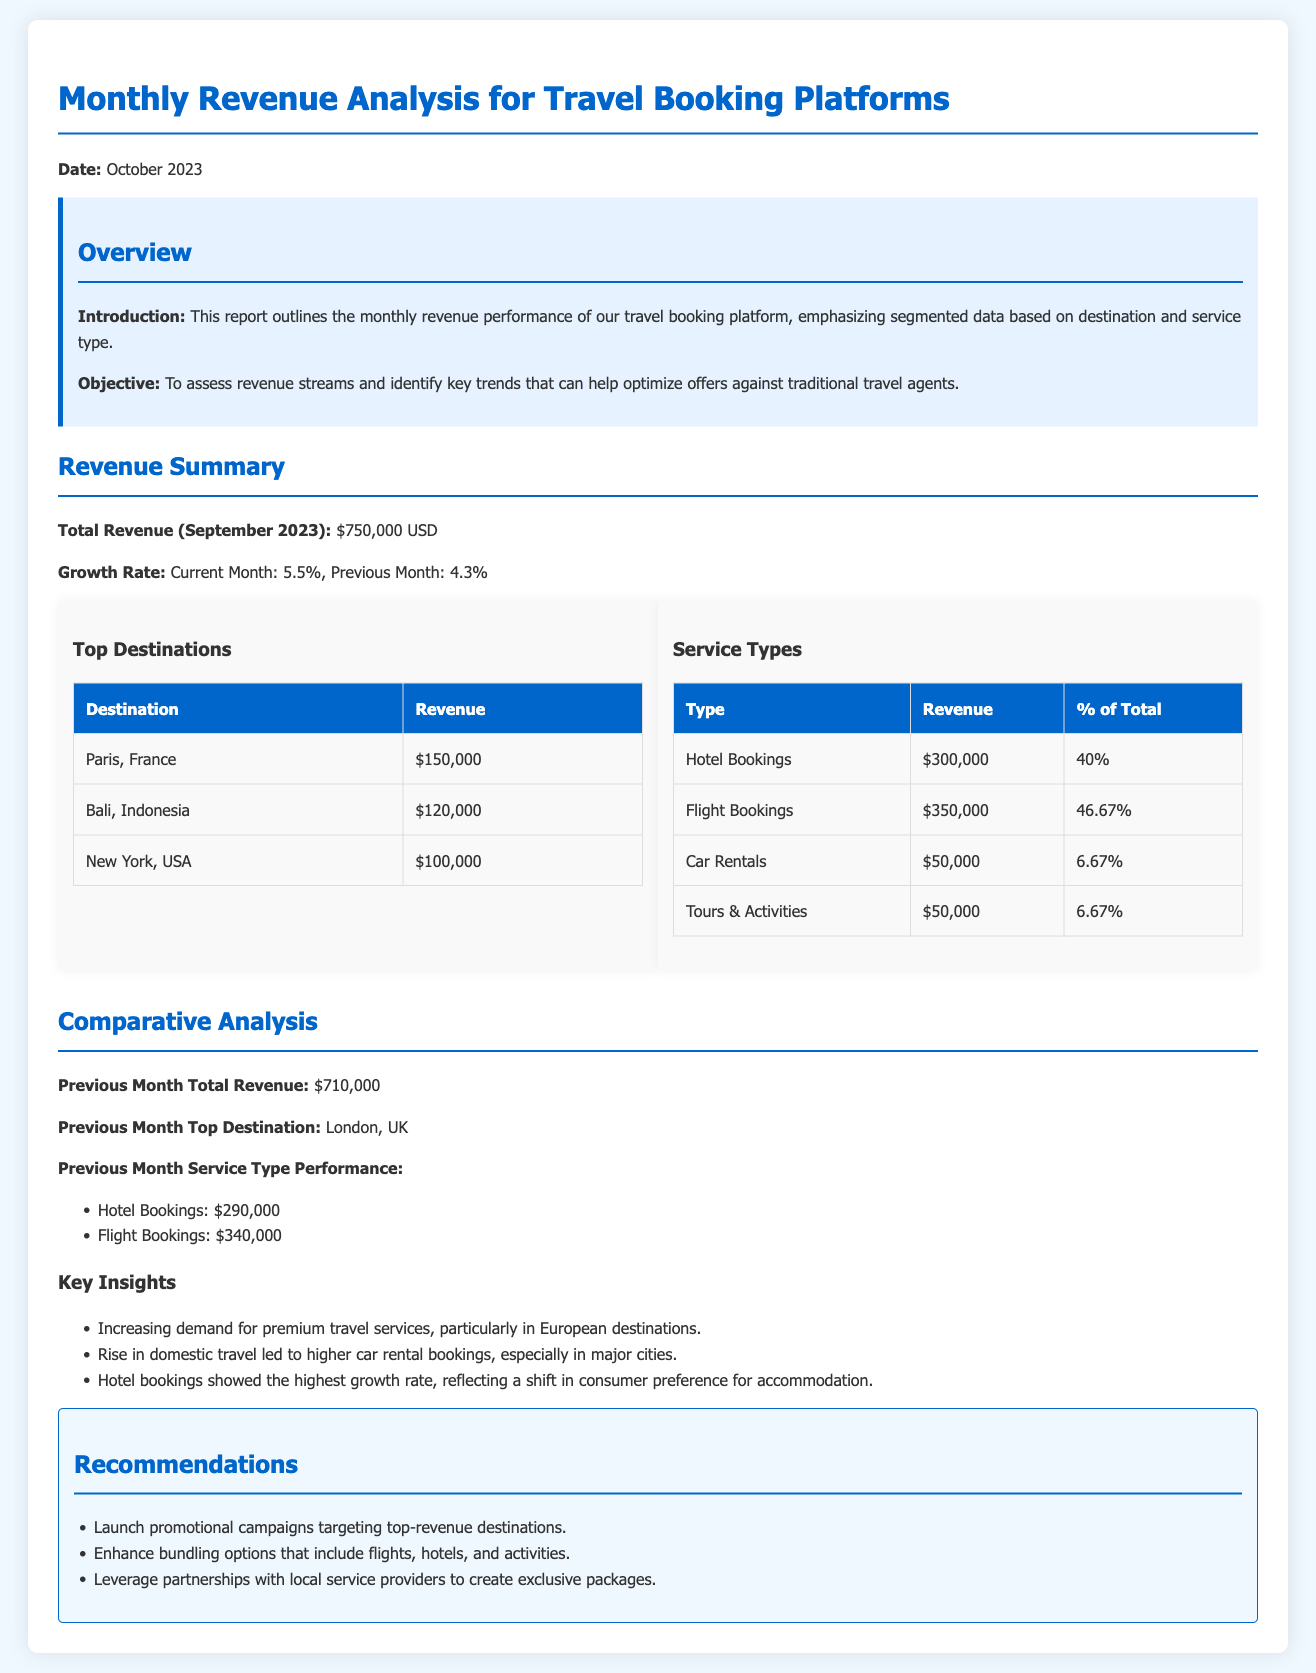What is the total revenue for September 2023? The total revenue is explicitly stated in the document under the revenue summary section.
Answer: $750,000 USD What was the growth rate for the current month? The document specifies the growth rate for the current month as indicated in the revenue summary section.
Answer: 5.5% Which destination generated the highest revenue? The top destinations table shows the revenue generated from each destination, indicating the highest one.
Answer: Paris, France What percentage of total revenue did flight bookings account for? The table for service types provides percentages for each service type, including flight bookings.
Answer: 46.67% What was the previous month's total revenue? The document provides historical comparison data in the comparative analysis section, showing previous month’s revenue.
Answer: $710,000 Which service type showed the highest revenue growth? Insights derived from the key insights section indicate which service types performed best compared to previous periods.
Answer: Hotel bookings What were the recommendations based on the revenue analysis? The recommendations section lists specific strategies based on the revenue findings.
Answer: Launch promotional campaigns targeting top-revenue destinations What is the date of the report? The report specifies the date at the beginning of the document for context.
Answer: October 2023 What was the previous month's top destination? The comparative analysis section indicates which destination was the top performer in the previous month.
Answer: London, UK 